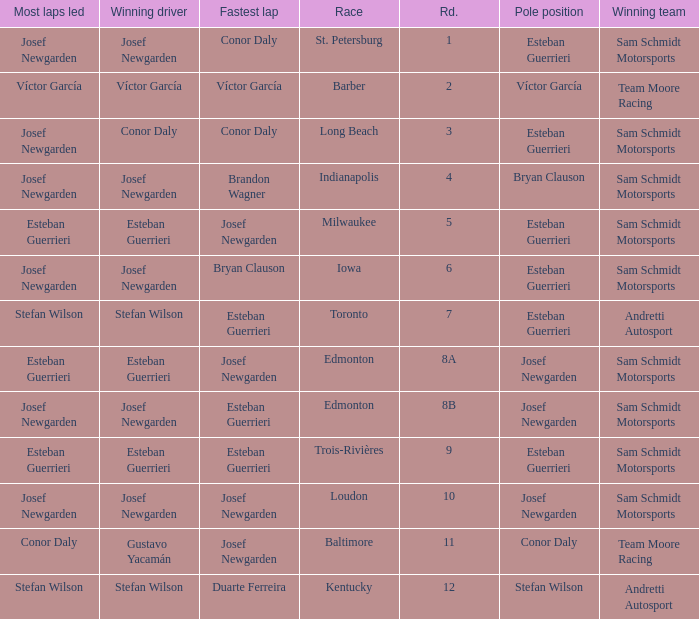What race did josef newgarden have the fastest lap and lead the most laps? Loudon. 